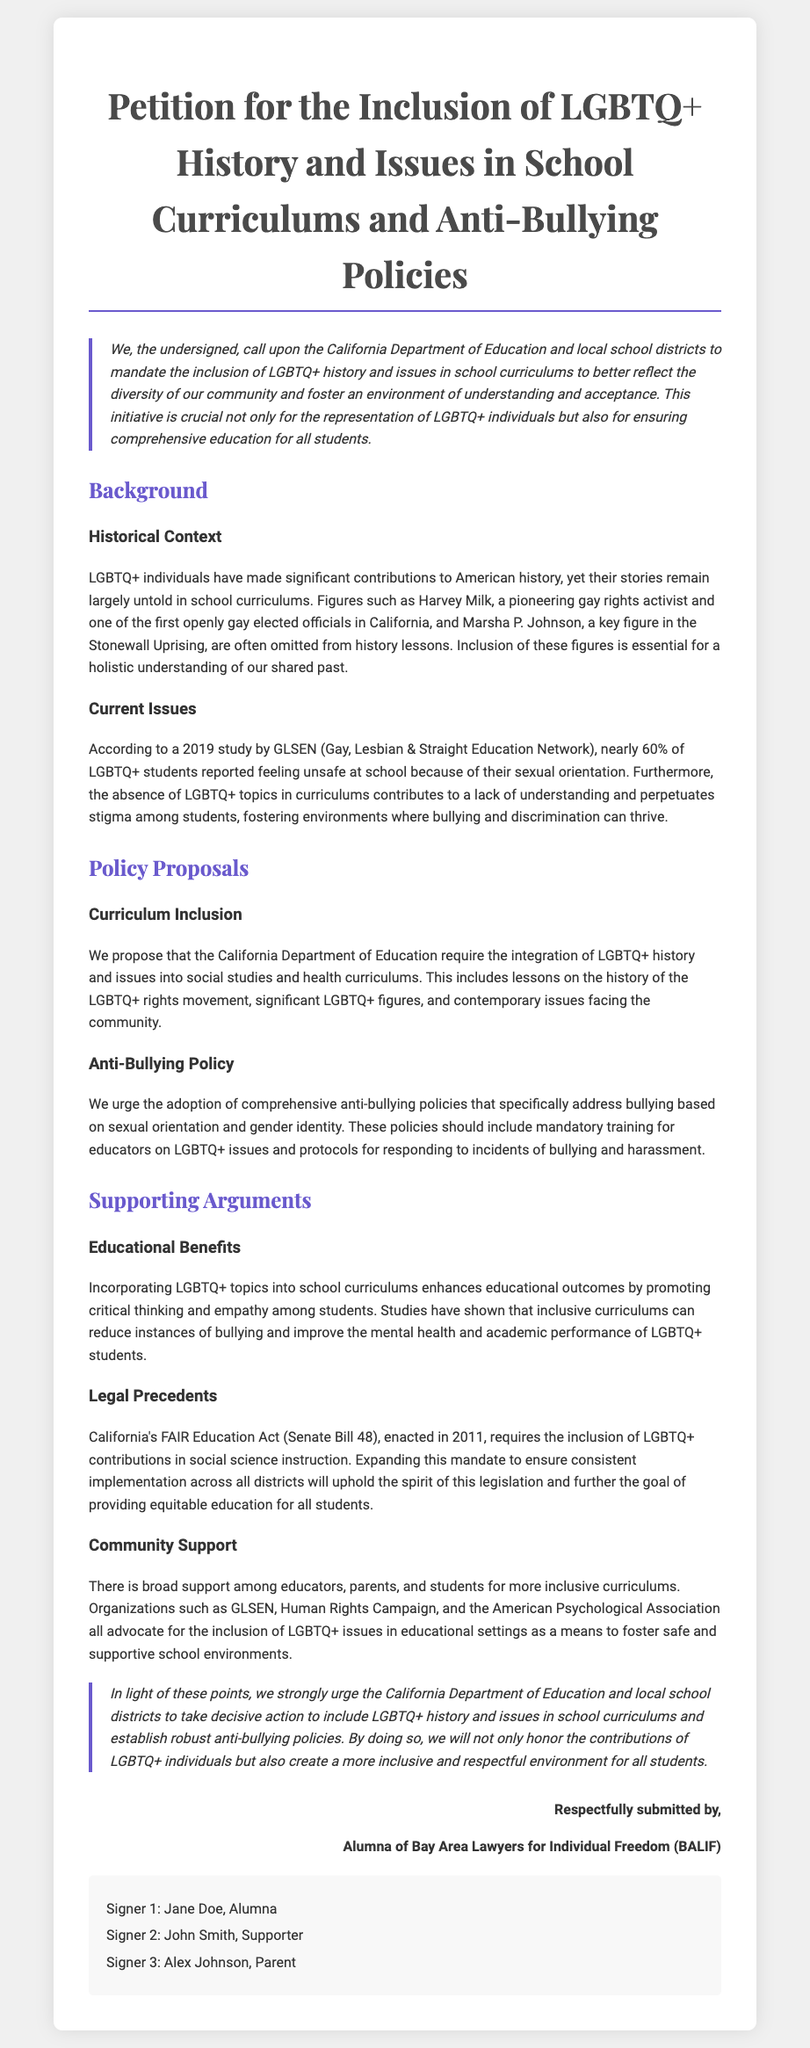What is the title of the petition? The title is prominently displayed at the top of the document.
Answer: Petition for the Inclusion of LGBTQ+ History and Issues in School Curriculums and Anti-Bullying Policies Who is called upon in the petition? The petition specifies the California Department of Education and local school districts.
Answer: California Department of Education and local school districts What percentage of LGBTQ+ students feel unsafe at school? The document includes a statistic from a study regarding LGBTQ+ students feeling unsafe.
Answer: Nearly 60% What significant historical figure is mentioned in the petition? The document references LGBTQ+ individuals who made contributions to history, including specific names.
Answer: Harvey Milk What legal act is referenced in the supporting arguments? The petition discusses specific legislation related to LGBTQ+ education in California.
Answer: FAIR Education Act (Senate Bill 48) What are the two main policy proposals? The document outlines specific proposals aimed at enhancing education and safety for LGBTQ+ students.
Answer: Curriculum Inclusion and Anti-Bullying Policy What do the supporting organizations advocate for? The petition mentions the stance of various organizations regarding LGBTQ+ issues in education.
Answer: Inclusion of LGBTQ+ issues in educational settings What style is used for the introduction and conclusion sections? The document uses a specific format to highlight certain parts, which is mentioned in the description.
Answer: Italic style with a border on the left 